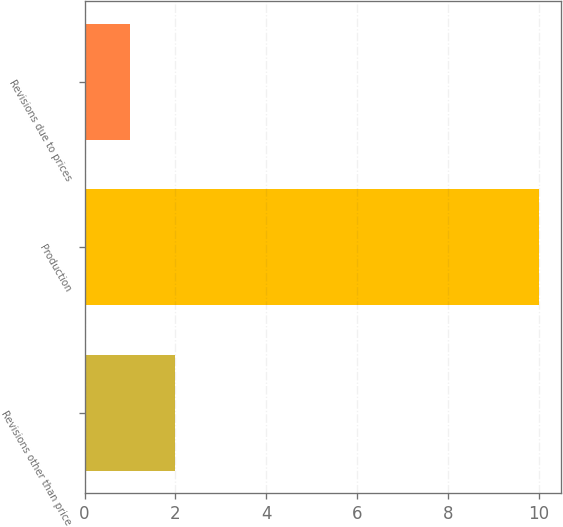Convert chart. <chart><loc_0><loc_0><loc_500><loc_500><bar_chart><fcel>Revisions other than price<fcel>Production<fcel>Revisions due to prices<nl><fcel>2<fcel>10<fcel>1<nl></chart> 